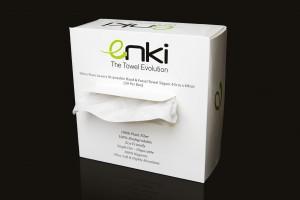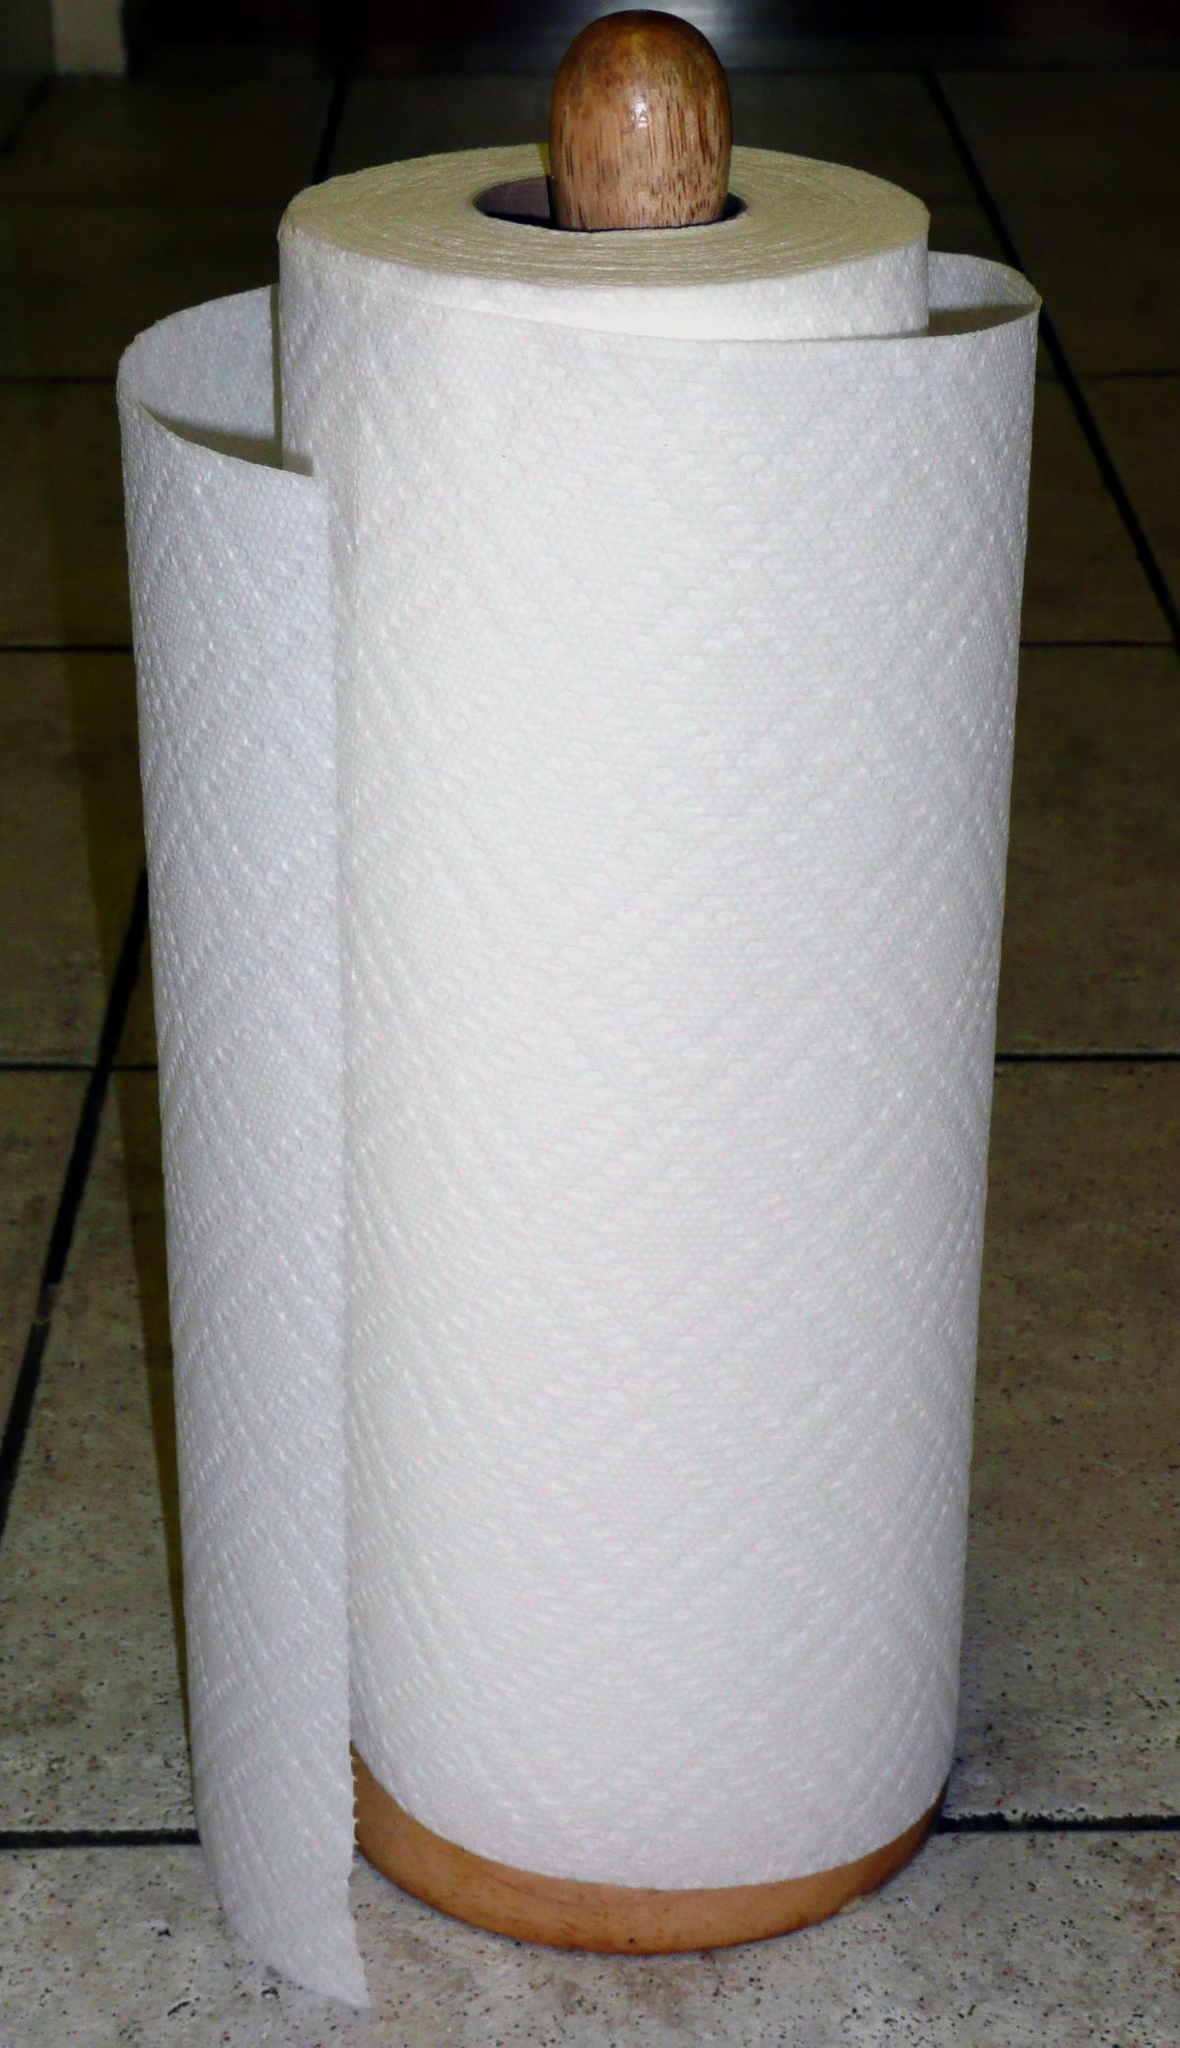The first image is the image on the left, the second image is the image on the right. Assess this claim about the two images: "At least six rolls of paper towels are divided into segments of one roll and the remaining rolls.". Correct or not? Answer yes or no. No. The first image is the image on the left, the second image is the image on the right. Examine the images to the left and right. Is the description "One image shows white paper towels that are not in roll format." accurate? Answer yes or no. Yes. 